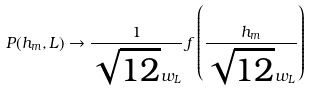<formula> <loc_0><loc_0><loc_500><loc_500>P ( h _ { m } , L ) \to \frac { 1 } { \sqrt { 1 2 } w _ { L } } \, f \left ( \frac { h _ { m } } { \sqrt { 1 2 } w _ { L } } \right )</formula> 